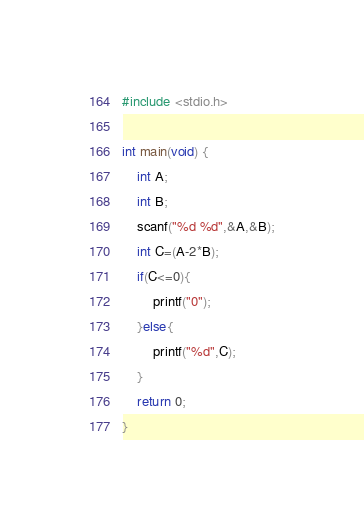Convert code to text. <code><loc_0><loc_0><loc_500><loc_500><_C_>#include <stdio.h>

int main(void) {
	int A;
	int B;
	scanf("%d %d",&A,&B);
	int C=(A-2*B);
	if(C<=0){
		printf("0");
	}else{
		printf("%d",C);
	}
	return 0;
}
</code> 